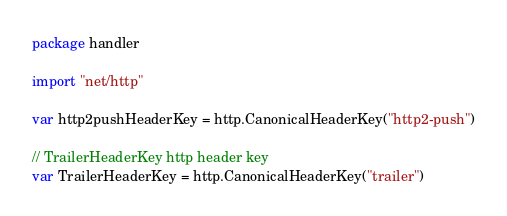<code> <loc_0><loc_0><loc_500><loc_500><_Go_>package handler

import "net/http"

var http2pushHeaderKey = http.CanonicalHeaderKey("http2-push")

// TrailerHeaderKey http header key
var TrailerHeaderKey = http.CanonicalHeaderKey("trailer")
</code> 